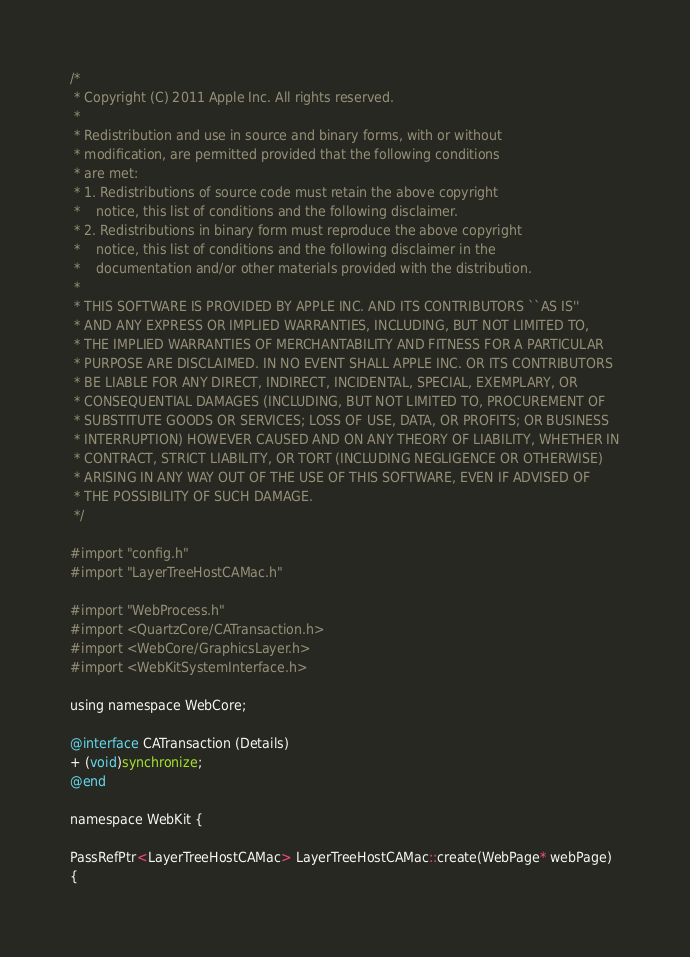<code> <loc_0><loc_0><loc_500><loc_500><_ObjectiveC_>/*
 * Copyright (C) 2011 Apple Inc. All rights reserved.
 *
 * Redistribution and use in source and binary forms, with or without
 * modification, are permitted provided that the following conditions
 * are met:
 * 1. Redistributions of source code must retain the above copyright
 *    notice, this list of conditions and the following disclaimer.
 * 2. Redistributions in binary form must reproduce the above copyright
 *    notice, this list of conditions and the following disclaimer in the
 *    documentation and/or other materials provided with the distribution.
 *
 * THIS SOFTWARE IS PROVIDED BY APPLE INC. AND ITS CONTRIBUTORS ``AS IS''
 * AND ANY EXPRESS OR IMPLIED WARRANTIES, INCLUDING, BUT NOT LIMITED TO,
 * THE IMPLIED WARRANTIES OF MERCHANTABILITY AND FITNESS FOR A PARTICULAR
 * PURPOSE ARE DISCLAIMED. IN NO EVENT SHALL APPLE INC. OR ITS CONTRIBUTORS
 * BE LIABLE FOR ANY DIRECT, INDIRECT, INCIDENTAL, SPECIAL, EXEMPLARY, OR
 * CONSEQUENTIAL DAMAGES (INCLUDING, BUT NOT LIMITED TO, PROCUREMENT OF
 * SUBSTITUTE GOODS OR SERVICES; LOSS OF USE, DATA, OR PROFITS; OR BUSINESS
 * INTERRUPTION) HOWEVER CAUSED AND ON ANY THEORY OF LIABILITY, WHETHER IN
 * CONTRACT, STRICT LIABILITY, OR TORT (INCLUDING NEGLIGENCE OR OTHERWISE)
 * ARISING IN ANY WAY OUT OF THE USE OF THIS SOFTWARE, EVEN IF ADVISED OF
 * THE POSSIBILITY OF SUCH DAMAGE.
 */

#import "config.h"
#import "LayerTreeHostCAMac.h"

#import "WebProcess.h"
#import <QuartzCore/CATransaction.h>
#import <WebCore/GraphicsLayer.h>
#import <WebKitSystemInterface.h>

using namespace WebCore;

@interface CATransaction (Details)
+ (void)synchronize;
@end

namespace WebKit {

PassRefPtr<LayerTreeHostCAMac> LayerTreeHostCAMac::create(WebPage* webPage)
{</code> 